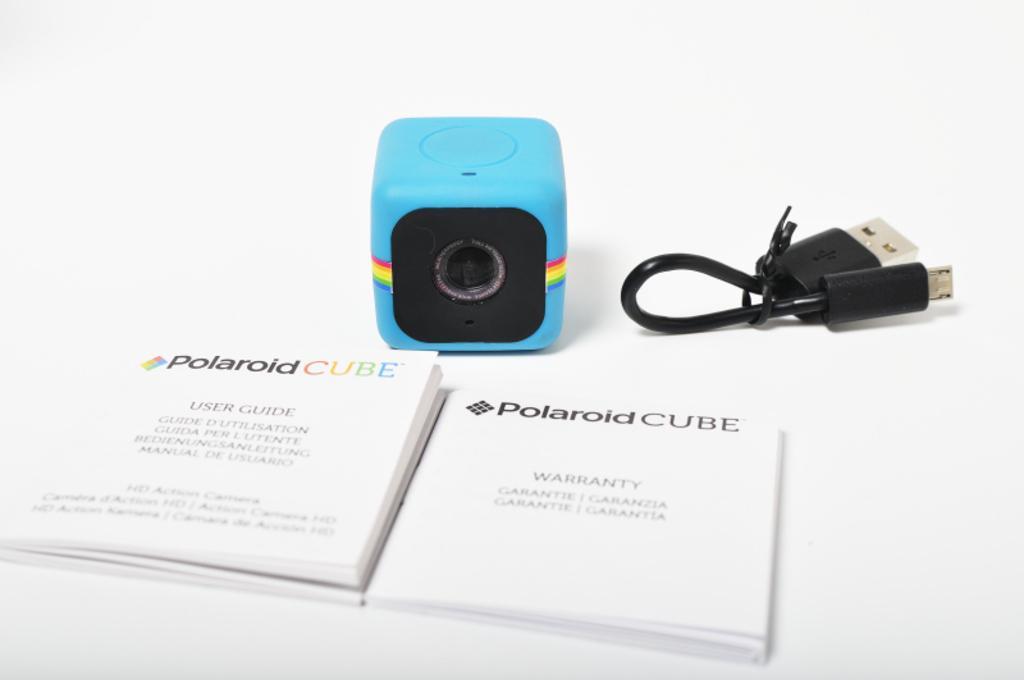Please provide a concise description of this image. In this image we can see the books, camera and a cable, also we can see the background is white. 